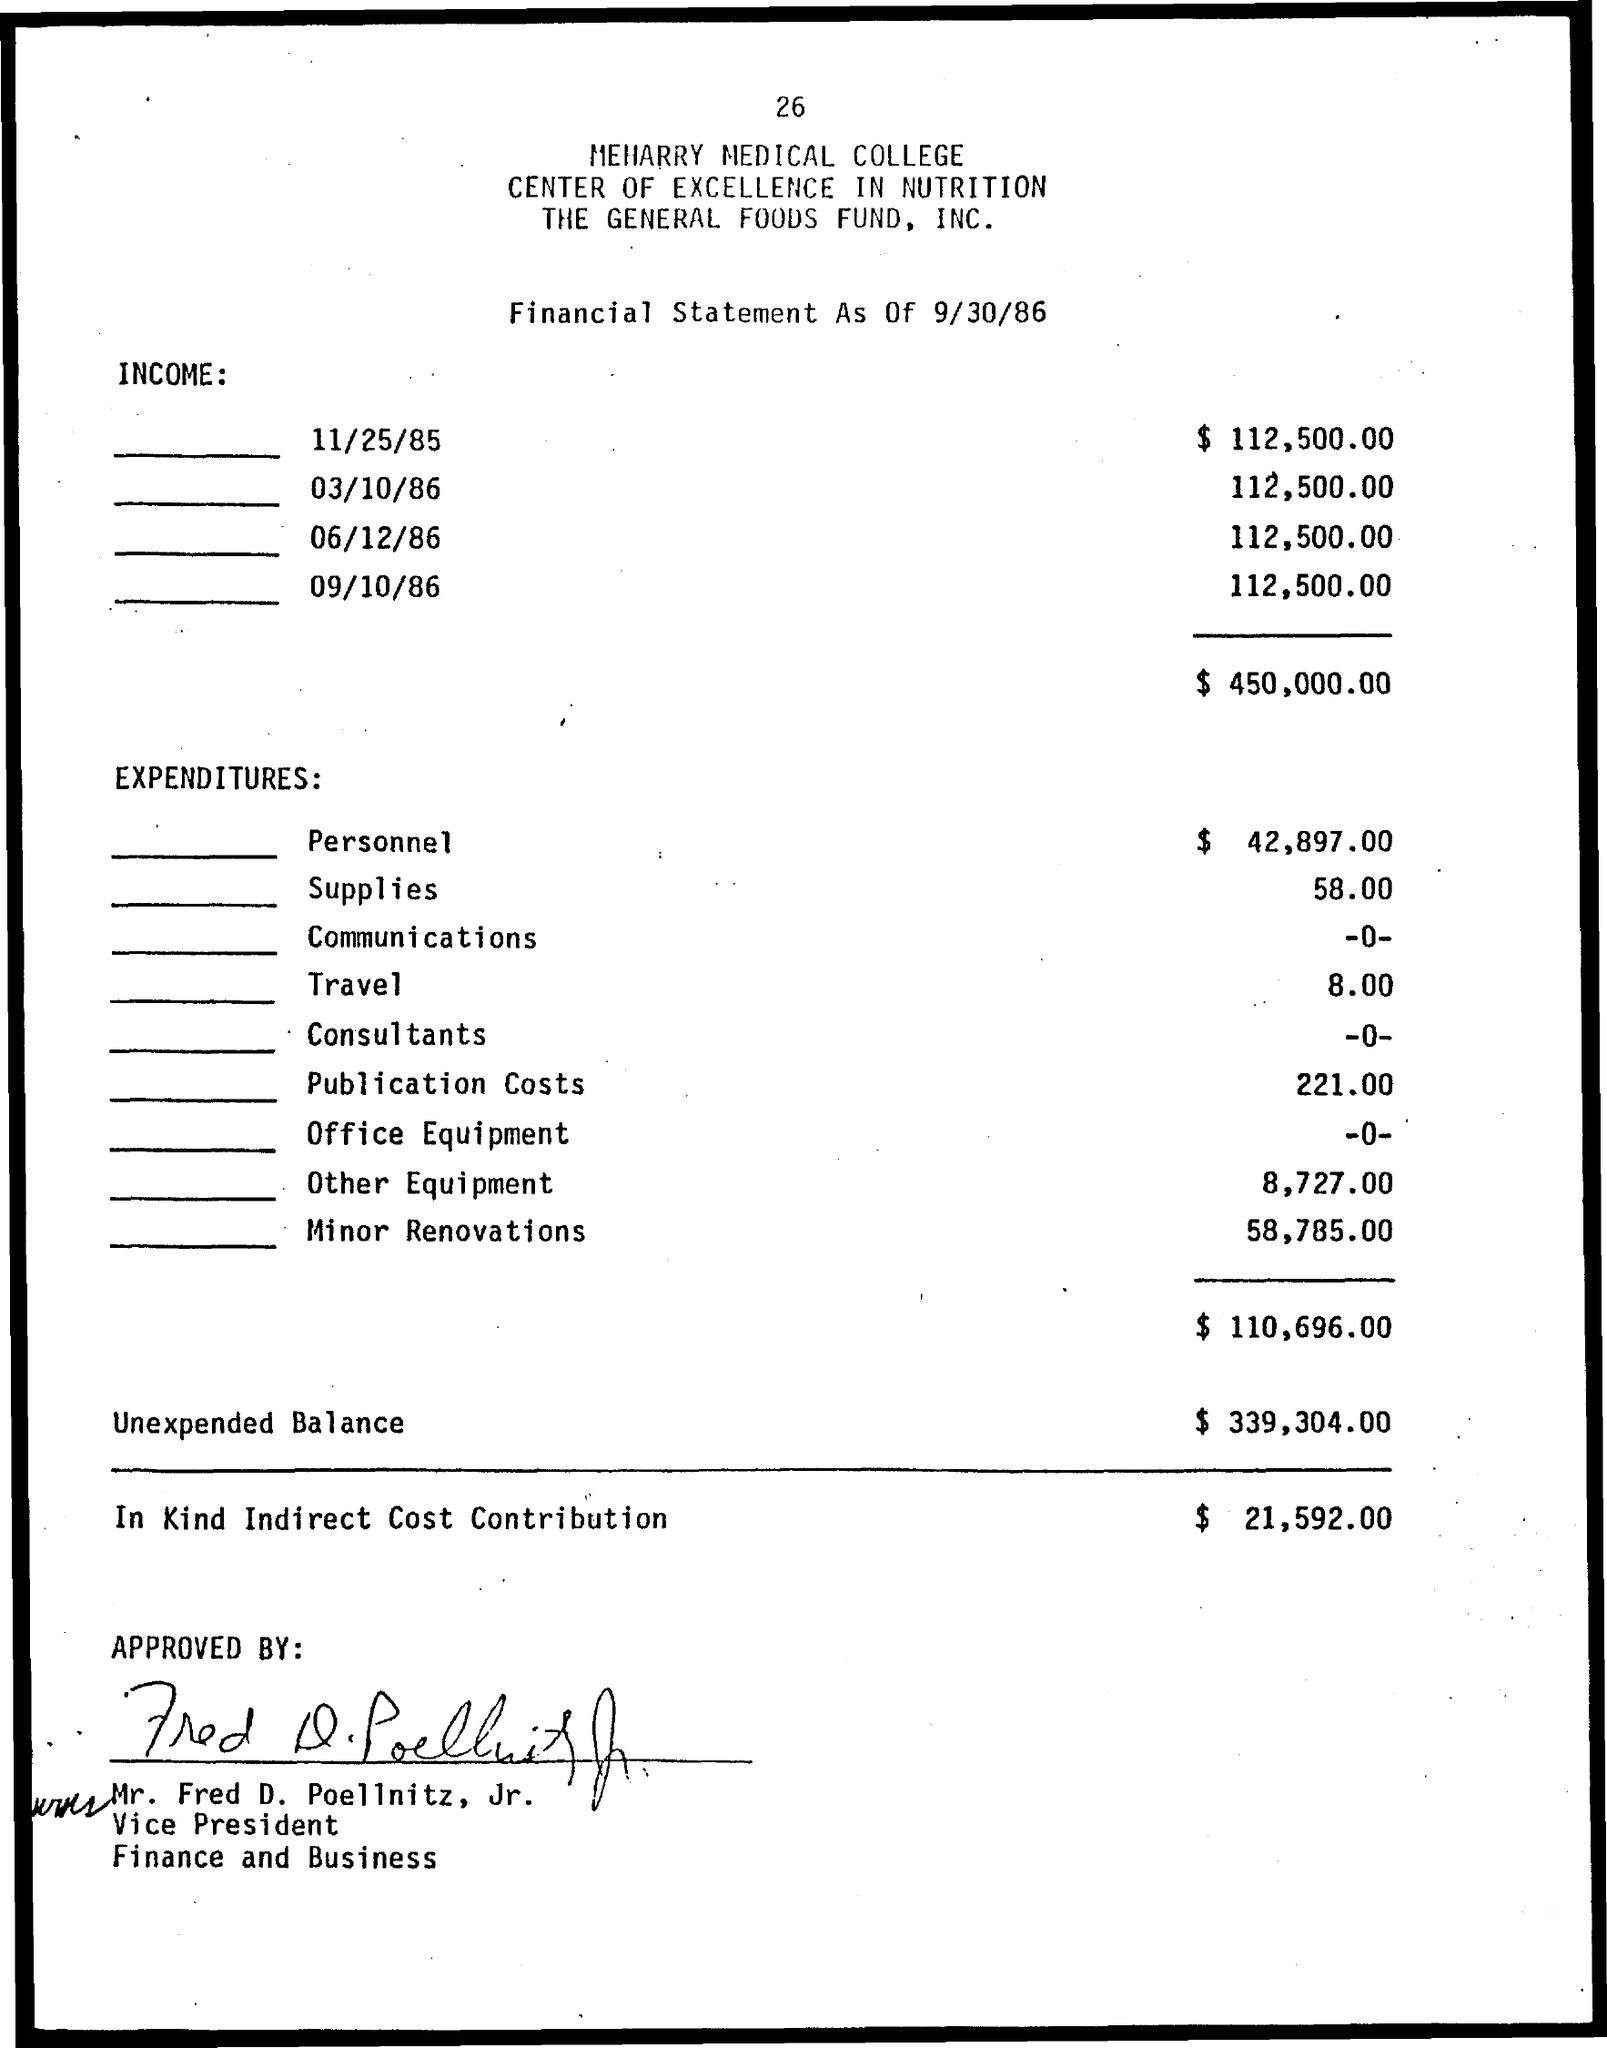List a handful of essential elements in this visual. The unexpended balance as of September 30, 2022, is $339,304.00. The total amount for travel is 8.00. The supplies amount is 58.00. The total income is $450,000.00. 